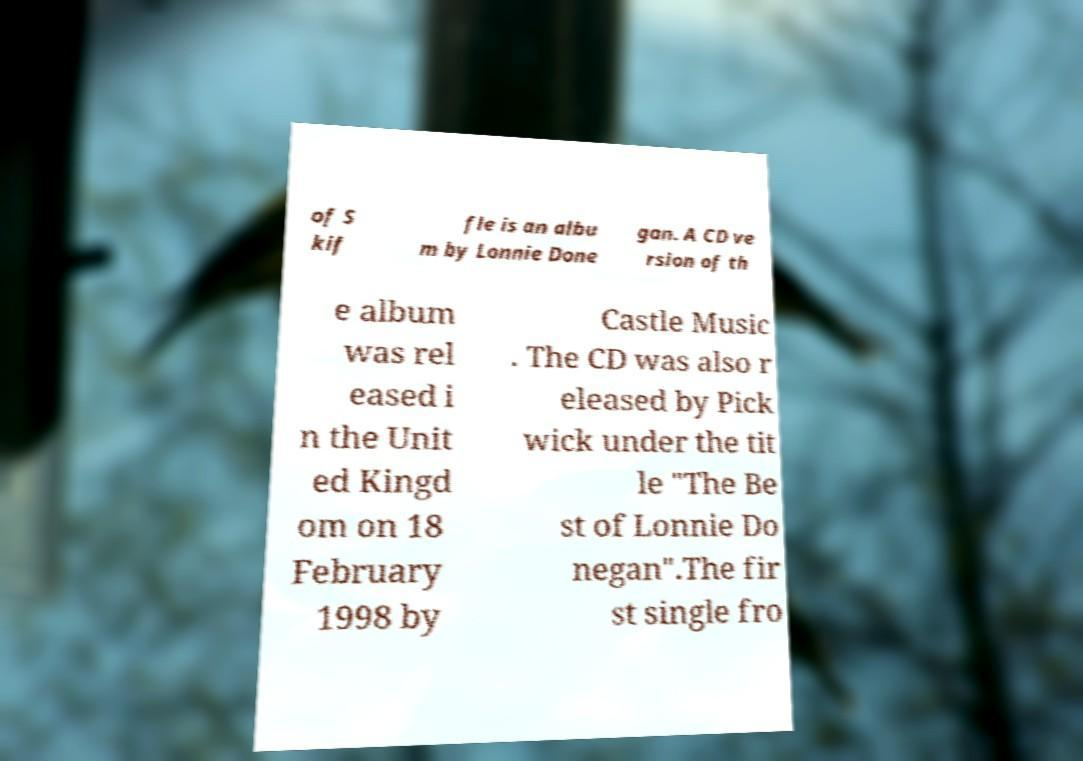Can you read and provide the text displayed in the image?This photo seems to have some interesting text. Can you extract and type it out for me? of S kif fle is an albu m by Lonnie Done gan. A CD ve rsion of th e album was rel eased i n the Unit ed Kingd om on 18 February 1998 by Castle Music . The CD was also r eleased by Pick wick under the tit le "The Be st of Lonnie Do negan".The fir st single fro 